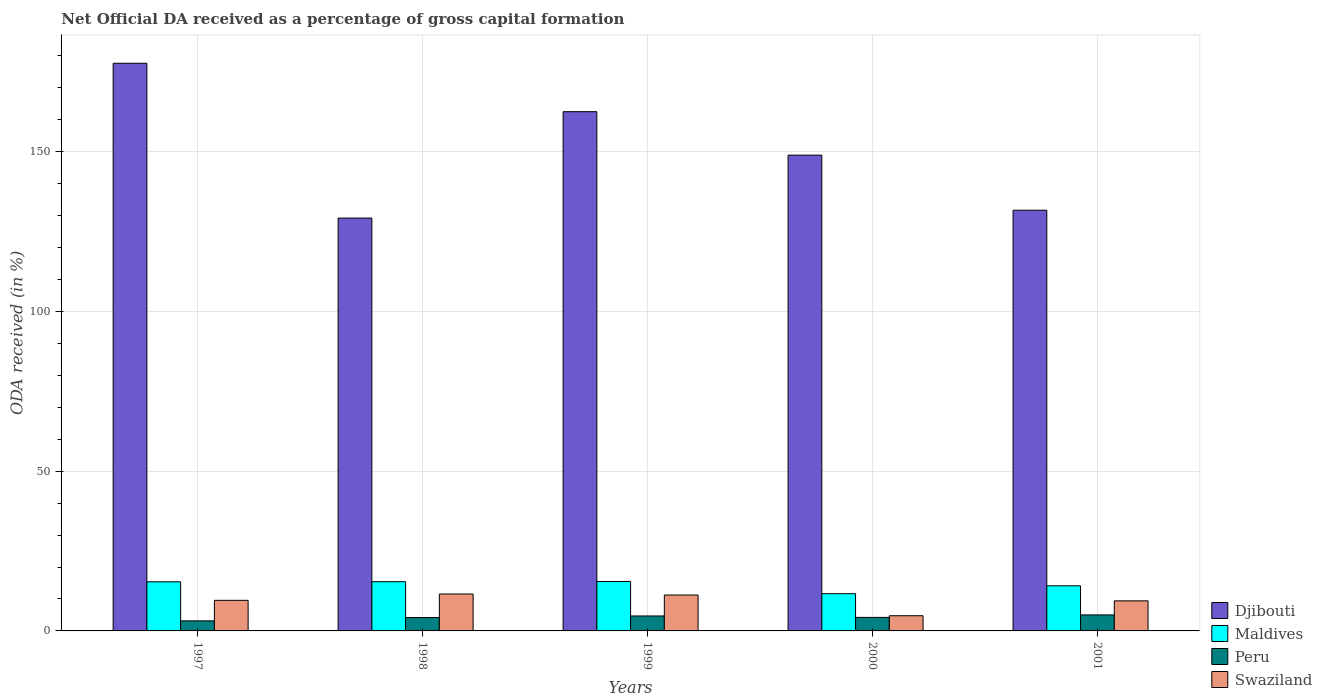How many different coloured bars are there?
Provide a succinct answer. 4. How many bars are there on the 1st tick from the right?
Your answer should be very brief. 4. What is the net ODA received in Djibouti in 1998?
Make the answer very short. 129.18. Across all years, what is the maximum net ODA received in Swaziland?
Your response must be concise. 11.55. Across all years, what is the minimum net ODA received in Djibouti?
Offer a terse response. 129.18. In which year was the net ODA received in Djibouti minimum?
Your response must be concise. 1998. What is the total net ODA received in Peru in the graph?
Your response must be concise. 21.26. What is the difference between the net ODA received in Maldives in 1997 and that in 1998?
Provide a short and direct response. -0.04. What is the difference between the net ODA received in Peru in 2001 and the net ODA received in Djibouti in 1999?
Your answer should be very brief. -157.46. What is the average net ODA received in Peru per year?
Your response must be concise. 4.25. In the year 1997, what is the difference between the net ODA received in Peru and net ODA received in Swaziland?
Your answer should be compact. -6.42. In how many years, is the net ODA received in Swaziland greater than 160 %?
Your response must be concise. 0. What is the ratio of the net ODA received in Peru in 2000 to that in 2001?
Your answer should be very brief. 0.84. Is the net ODA received in Djibouti in 1997 less than that in 2001?
Give a very brief answer. No. Is the difference between the net ODA received in Peru in 1997 and 1998 greater than the difference between the net ODA received in Swaziland in 1997 and 1998?
Your answer should be compact. Yes. What is the difference between the highest and the second highest net ODA received in Djibouti?
Your answer should be compact. 15.15. What is the difference between the highest and the lowest net ODA received in Maldives?
Make the answer very short. 3.83. What does the 4th bar from the left in 2001 represents?
Offer a very short reply. Swaziland. How many bars are there?
Make the answer very short. 20. Does the graph contain any zero values?
Give a very brief answer. No. What is the title of the graph?
Make the answer very short. Net Official DA received as a percentage of gross capital formation. What is the label or title of the Y-axis?
Provide a succinct answer. ODA received (in %). What is the ODA received (in %) in Djibouti in 1997?
Provide a succinct answer. 177.62. What is the ODA received (in %) in Maldives in 1997?
Give a very brief answer. 15.37. What is the ODA received (in %) in Peru in 1997?
Your answer should be compact. 3.14. What is the ODA received (in %) in Swaziland in 1997?
Your answer should be very brief. 9.57. What is the ODA received (in %) of Djibouti in 1998?
Give a very brief answer. 129.18. What is the ODA received (in %) in Maldives in 1998?
Give a very brief answer. 15.4. What is the ODA received (in %) of Peru in 1998?
Make the answer very short. 4.19. What is the ODA received (in %) in Swaziland in 1998?
Your answer should be very brief. 11.55. What is the ODA received (in %) of Djibouti in 1999?
Make the answer very short. 162.47. What is the ODA received (in %) in Maldives in 1999?
Give a very brief answer. 15.48. What is the ODA received (in %) of Peru in 1999?
Keep it short and to the point. 4.68. What is the ODA received (in %) of Swaziland in 1999?
Offer a terse response. 11.23. What is the ODA received (in %) of Djibouti in 2000?
Provide a succinct answer. 148.87. What is the ODA received (in %) in Maldives in 2000?
Offer a very short reply. 11.65. What is the ODA received (in %) of Peru in 2000?
Make the answer very short. 4.23. What is the ODA received (in %) in Swaziland in 2000?
Your answer should be very brief. 4.75. What is the ODA received (in %) in Djibouti in 2001?
Provide a succinct answer. 131.64. What is the ODA received (in %) in Maldives in 2001?
Give a very brief answer. 14.12. What is the ODA received (in %) in Peru in 2001?
Offer a very short reply. 5.01. What is the ODA received (in %) of Swaziland in 2001?
Your answer should be compact. 9.41. Across all years, what is the maximum ODA received (in %) in Djibouti?
Keep it short and to the point. 177.62. Across all years, what is the maximum ODA received (in %) of Maldives?
Offer a terse response. 15.48. Across all years, what is the maximum ODA received (in %) in Peru?
Your answer should be very brief. 5.01. Across all years, what is the maximum ODA received (in %) of Swaziland?
Give a very brief answer. 11.55. Across all years, what is the minimum ODA received (in %) of Djibouti?
Offer a terse response. 129.18. Across all years, what is the minimum ODA received (in %) of Maldives?
Provide a short and direct response. 11.65. Across all years, what is the minimum ODA received (in %) in Peru?
Offer a very short reply. 3.14. Across all years, what is the minimum ODA received (in %) in Swaziland?
Give a very brief answer. 4.75. What is the total ODA received (in %) of Djibouti in the graph?
Your response must be concise. 749.77. What is the total ODA received (in %) in Maldives in the graph?
Keep it short and to the point. 72.01. What is the total ODA received (in %) in Peru in the graph?
Provide a succinct answer. 21.26. What is the total ODA received (in %) of Swaziland in the graph?
Your answer should be very brief. 46.51. What is the difference between the ODA received (in %) in Djibouti in 1997 and that in 1998?
Your answer should be very brief. 48.44. What is the difference between the ODA received (in %) of Maldives in 1997 and that in 1998?
Provide a succinct answer. -0.04. What is the difference between the ODA received (in %) in Peru in 1997 and that in 1998?
Ensure brevity in your answer.  -1.04. What is the difference between the ODA received (in %) of Swaziland in 1997 and that in 1998?
Your response must be concise. -1.98. What is the difference between the ODA received (in %) in Djibouti in 1997 and that in 1999?
Ensure brevity in your answer.  15.15. What is the difference between the ODA received (in %) in Maldives in 1997 and that in 1999?
Keep it short and to the point. -0.11. What is the difference between the ODA received (in %) of Peru in 1997 and that in 1999?
Keep it short and to the point. -1.54. What is the difference between the ODA received (in %) of Swaziland in 1997 and that in 1999?
Offer a terse response. -1.66. What is the difference between the ODA received (in %) of Djibouti in 1997 and that in 2000?
Offer a very short reply. 28.75. What is the difference between the ODA received (in %) in Maldives in 1997 and that in 2000?
Your answer should be very brief. 3.71. What is the difference between the ODA received (in %) in Peru in 1997 and that in 2000?
Your answer should be compact. -1.09. What is the difference between the ODA received (in %) of Swaziland in 1997 and that in 2000?
Keep it short and to the point. 4.81. What is the difference between the ODA received (in %) in Djibouti in 1997 and that in 2001?
Your answer should be very brief. 45.98. What is the difference between the ODA received (in %) of Maldives in 1997 and that in 2001?
Your answer should be compact. 1.25. What is the difference between the ODA received (in %) of Peru in 1997 and that in 2001?
Provide a short and direct response. -1.86. What is the difference between the ODA received (in %) of Swaziland in 1997 and that in 2001?
Provide a short and direct response. 0.16. What is the difference between the ODA received (in %) in Djibouti in 1998 and that in 1999?
Give a very brief answer. -33.29. What is the difference between the ODA received (in %) of Maldives in 1998 and that in 1999?
Your response must be concise. -0.08. What is the difference between the ODA received (in %) of Peru in 1998 and that in 1999?
Offer a terse response. -0.49. What is the difference between the ODA received (in %) in Swaziland in 1998 and that in 1999?
Provide a succinct answer. 0.32. What is the difference between the ODA received (in %) in Djibouti in 1998 and that in 2000?
Provide a succinct answer. -19.69. What is the difference between the ODA received (in %) of Maldives in 1998 and that in 2000?
Provide a succinct answer. 3.75. What is the difference between the ODA received (in %) of Peru in 1998 and that in 2000?
Your answer should be compact. -0.04. What is the difference between the ODA received (in %) of Swaziland in 1998 and that in 2000?
Provide a short and direct response. 6.8. What is the difference between the ODA received (in %) of Djibouti in 1998 and that in 2001?
Keep it short and to the point. -2.46. What is the difference between the ODA received (in %) in Maldives in 1998 and that in 2001?
Ensure brevity in your answer.  1.28. What is the difference between the ODA received (in %) of Peru in 1998 and that in 2001?
Your answer should be compact. -0.82. What is the difference between the ODA received (in %) of Swaziland in 1998 and that in 2001?
Offer a terse response. 2.15. What is the difference between the ODA received (in %) in Djibouti in 1999 and that in 2000?
Ensure brevity in your answer.  13.6. What is the difference between the ODA received (in %) in Maldives in 1999 and that in 2000?
Keep it short and to the point. 3.83. What is the difference between the ODA received (in %) of Peru in 1999 and that in 2000?
Make the answer very short. 0.45. What is the difference between the ODA received (in %) of Swaziland in 1999 and that in 2000?
Ensure brevity in your answer.  6.48. What is the difference between the ODA received (in %) in Djibouti in 1999 and that in 2001?
Your answer should be compact. 30.83. What is the difference between the ODA received (in %) in Maldives in 1999 and that in 2001?
Ensure brevity in your answer.  1.36. What is the difference between the ODA received (in %) of Peru in 1999 and that in 2001?
Keep it short and to the point. -0.33. What is the difference between the ODA received (in %) in Swaziland in 1999 and that in 2001?
Your response must be concise. 1.82. What is the difference between the ODA received (in %) of Djibouti in 2000 and that in 2001?
Offer a terse response. 17.23. What is the difference between the ODA received (in %) in Maldives in 2000 and that in 2001?
Offer a very short reply. -2.46. What is the difference between the ODA received (in %) of Peru in 2000 and that in 2001?
Ensure brevity in your answer.  -0.78. What is the difference between the ODA received (in %) of Swaziland in 2000 and that in 2001?
Ensure brevity in your answer.  -4.65. What is the difference between the ODA received (in %) in Djibouti in 1997 and the ODA received (in %) in Maldives in 1998?
Make the answer very short. 162.22. What is the difference between the ODA received (in %) in Djibouti in 1997 and the ODA received (in %) in Peru in 1998?
Provide a short and direct response. 173.43. What is the difference between the ODA received (in %) in Djibouti in 1997 and the ODA received (in %) in Swaziland in 1998?
Ensure brevity in your answer.  166.07. What is the difference between the ODA received (in %) in Maldives in 1997 and the ODA received (in %) in Peru in 1998?
Provide a short and direct response. 11.18. What is the difference between the ODA received (in %) in Maldives in 1997 and the ODA received (in %) in Swaziland in 1998?
Your answer should be compact. 3.81. What is the difference between the ODA received (in %) of Peru in 1997 and the ODA received (in %) of Swaziland in 1998?
Your answer should be compact. -8.41. What is the difference between the ODA received (in %) in Djibouti in 1997 and the ODA received (in %) in Maldives in 1999?
Your response must be concise. 162.14. What is the difference between the ODA received (in %) of Djibouti in 1997 and the ODA received (in %) of Peru in 1999?
Offer a terse response. 172.94. What is the difference between the ODA received (in %) in Djibouti in 1997 and the ODA received (in %) in Swaziland in 1999?
Your response must be concise. 166.39. What is the difference between the ODA received (in %) in Maldives in 1997 and the ODA received (in %) in Peru in 1999?
Provide a short and direct response. 10.69. What is the difference between the ODA received (in %) in Maldives in 1997 and the ODA received (in %) in Swaziland in 1999?
Provide a succinct answer. 4.13. What is the difference between the ODA received (in %) of Peru in 1997 and the ODA received (in %) of Swaziland in 1999?
Offer a terse response. -8.09. What is the difference between the ODA received (in %) in Djibouti in 1997 and the ODA received (in %) in Maldives in 2000?
Your answer should be very brief. 165.96. What is the difference between the ODA received (in %) in Djibouti in 1997 and the ODA received (in %) in Peru in 2000?
Give a very brief answer. 173.39. What is the difference between the ODA received (in %) in Djibouti in 1997 and the ODA received (in %) in Swaziland in 2000?
Offer a terse response. 172.86. What is the difference between the ODA received (in %) in Maldives in 1997 and the ODA received (in %) in Peru in 2000?
Keep it short and to the point. 11.13. What is the difference between the ODA received (in %) in Maldives in 1997 and the ODA received (in %) in Swaziland in 2000?
Make the answer very short. 10.61. What is the difference between the ODA received (in %) in Peru in 1997 and the ODA received (in %) in Swaziland in 2000?
Your answer should be compact. -1.61. What is the difference between the ODA received (in %) in Djibouti in 1997 and the ODA received (in %) in Maldives in 2001?
Provide a short and direct response. 163.5. What is the difference between the ODA received (in %) in Djibouti in 1997 and the ODA received (in %) in Peru in 2001?
Offer a terse response. 172.61. What is the difference between the ODA received (in %) in Djibouti in 1997 and the ODA received (in %) in Swaziland in 2001?
Offer a very short reply. 168.21. What is the difference between the ODA received (in %) in Maldives in 1997 and the ODA received (in %) in Peru in 2001?
Offer a terse response. 10.36. What is the difference between the ODA received (in %) of Maldives in 1997 and the ODA received (in %) of Swaziland in 2001?
Keep it short and to the point. 5.96. What is the difference between the ODA received (in %) of Peru in 1997 and the ODA received (in %) of Swaziland in 2001?
Make the answer very short. -6.26. What is the difference between the ODA received (in %) of Djibouti in 1998 and the ODA received (in %) of Maldives in 1999?
Your answer should be compact. 113.7. What is the difference between the ODA received (in %) of Djibouti in 1998 and the ODA received (in %) of Peru in 1999?
Give a very brief answer. 124.5. What is the difference between the ODA received (in %) in Djibouti in 1998 and the ODA received (in %) in Swaziland in 1999?
Ensure brevity in your answer.  117.95. What is the difference between the ODA received (in %) in Maldives in 1998 and the ODA received (in %) in Peru in 1999?
Your answer should be compact. 10.72. What is the difference between the ODA received (in %) of Maldives in 1998 and the ODA received (in %) of Swaziland in 1999?
Offer a very short reply. 4.17. What is the difference between the ODA received (in %) of Peru in 1998 and the ODA received (in %) of Swaziland in 1999?
Provide a short and direct response. -7.04. What is the difference between the ODA received (in %) of Djibouti in 1998 and the ODA received (in %) of Maldives in 2000?
Provide a short and direct response. 117.53. What is the difference between the ODA received (in %) of Djibouti in 1998 and the ODA received (in %) of Peru in 2000?
Ensure brevity in your answer.  124.95. What is the difference between the ODA received (in %) of Djibouti in 1998 and the ODA received (in %) of Swaziland in 2000?
Your answer should be very brief. 124.43. What is the difference between the ODA received (in %) of Maldives in 1998 and the ODA received (in %) of Peru in 2000?
Give a very brief answer. 11.17. What is the difference between the ODA received (in %) in Maldives in 1998 and the ODA received (in %) in Swaziland in 2000?
Make the answer very short. 10.65. What is the difference between the ODA received (in %) of Peru in 1998 and the ODA received (in %) of Swaziland in 2000?
Make the answer very short. -0.56. What is the difference between the ODA received (in %) in Djibouti in 1998 and the ODA received (in %) in Maldives in 2001?
Ensure brevity in your answer.  115.06. What is the difference between the ODA received (in %) in Djibouti in 1998 and the ODA received (in %) in Peru in 2001?
Keep it short and to the point. 124.17. What is the difference between the ODA received (in %) of Djibouti in 1998 and the ODA received (in %) of Swaziland in 2001?
Your answer should be compact. 119.77. What is the difference between the ODA received (in %) of Maldives in 1998 and the ODA received (in %) of Peru in 2001?
Provide a short and direct response. 10.39. What is the difference between the ODA received (in %) in Maldives in 1998 and the ODA received (in %) in Swaziland in 2001?
Your answer should be very brief. 6. What is the difference between the ODA received (in %) in Peru in 1998 and the ODA received (in %) in Swaziland in 2001?
Keep it short and to the point. -5.22. What is the difference between the ODA received (in %) in Djibouti in 1999 and the ODA received (in %) in Maldives in 2000?
Give a very brief answer. 150.82. What is the difference between the ODA received (in %) of Djibouti in 1999 and the ODA received (in %) of Peru in 2000?
Provide a succinct answer. 158.24. What is the difference between the ODA received (in %) in Djibouti in 1999 and the ODA received (in %) in Swaziland in 2000?
Offer a very short reply. 157.71. What is the difference between the ODA received (in %) of Maldives in 1999 and the ODA received (in %) of Peru in 2000?
Make the answer very short. 11.25. What is the difference between the ODA received (in %) in Maldives in 1999 and the ODA received (in %) in Swaziland in 2000?
Make the answer very short. 10.72. What is the difference between the ODA received (in %) of Peru in 1999 and the ODA received (in %) of Swaziland in 2000?
Offer a very short reply. -0.07. What is the difference between the ODA received (in %) in Djibouti in 1999 and the ODA received (in %) in Maldives in 2001?
Provide a short and direct response. 148.35. What is the difference between the ODA received (in %) of Djibouti in 1999 and the ODA received (in %) of Peru in 2001?
Your answer should be compact. 157.46. What is the difference between the ODA received (in %) of Djibouti in 1999 and the ODA received (in %) of Swaziland in 2001?
Ensure brevity in your answer.  153.06. What is the difference between the ODA received (in %) of Maldives in 1999 and the ODA received (in %) of Peru in 2001?
Ensure brevity in your answer.  10.47. What is the difference between the ODA received (in %) in Maldives in 1999 and the ODA received (in %) in Swaziland in 2001?
Ensure brevity in your answer.  6.07. What is the difference between the ODA received (in %) in Peru in 1999 and the ODA received (in %) in Swaziland in 2001?
Keep it short and to the point. -4.73. What is the difference between the ODA received (in %) in Djibouti in 2000 and the ODA received (in %) in Maldives in 2001?
Ensure brevity in your answer.  134.75. What is the difference between the ODA received (in %) in Djibouti in 2000 and the ODA received (in %) in Peru in 2001?
Your answer should be compact. 143.86. What is the difference between the ODA received (in %) of Djibouti in 2000 and the ODA received (in %) of Swaziland in 2001?
Your answer should be compact. 139.46. What is the difference between the ODA received (in %) of Maldives in 2000 and the ODA received (in %) of Peru in 2001?
Give a very brief answer. 6.64. What is the difference between the ODA received (in %) in Maldives in 2000 and the ODA received (in %) in Swaziland in 2001?
Offer a very short reply. 2.25. What is the difference between the ODA received (in %) in Peru in 2000 and the ODA received (in %) in Swaziland in 2001?
Keep it short and to the point. -5.18. What is the average ODA received (in %) in Djibouti per year?
Your response must be concise. 149.95. What is the average ODA received (in %) of Maldives per year?
Provide a short and direct response. 14.4. What is the average ODA received (in %) in Peru per year?
Keep it short and to the point. 4.25. What is the average ODA received (in %) in Swaziland per year?
Provide a short and direct response. 9.3. In the year 1997, what is the difference between the ODA received (in %) in Djibouti and ODA received (in %) in Maldives?
Offer a terse response. 162.25. In the year 1997, what is the difference between the ODA received (in %) of Djibouti and ODA received (in %) of Peru?
Offer a very short reply. 174.47. In the year 1997, what is the difference between the ODA received (in %) of Djibouti and ODA received (in %) of Swaziland?
Your answer should be very brief. 168.05. In the year 1997, what is the difference between the ODA received (in %) of Maldives and ODA received (in %) of Peru?
Keep it short and to the point. 12.22. In the year 1997, what is the difference between the ODA received (in %) in Maldives and ODA received (in %) in Swaziland?
Make the answer very short. 5.8. In the year 1997, what is the difference between the ODA received (in %) in Peru and ODA received (in %) in Swaziland?
Keep it short and to the point. -6.42. In the year 1998, what is the difference between the ODA received (in %) of Djibouti and ODA received (in %) of Maldives?
Provide a succinct answer. 113.78. In the year 1998, what is the difference between the ODA received (in %) in Djibouti and ODA received (in %) in Peru?
Offer a very short reply. 124.99. In the year 1998, what is the difference between the ODA received (in %) in Djibouti and ODA received (in %) in Swaziland?
Offer a terse response. 117.63. In the year 1998, what is the difference between the ODA received (in %) in Maldives and ODA received (in %) in Peru?
Your response must be concise. 11.21. In the year 1998, what is the difference between the ODA received (in %) in Maldives and ODA received (in %) in Swaziland?
Your response must be concise. 3.85. In the year 1998, what is the difference between the ODA received (in %) of Peru and ODA received (in %) of Swaziland?
Offer a terse response. -7.36. In the year 1999, what is the difference between the ODA received (in %) of Djibouti and ODA received (in %) of Maldives?
Keep it short and to the point. 146.99. In the year 1999, what is the difference between the ODA received (in %) in Djibouti and ODA received (in %) in Peru?
Ensure brevity in your answer.  157.79. In the year 1999, what is the difference between the ODA received (in %) in Djibouti and ODA received (in %) in Swaziland?
Give a very brief answer. 151.24. In the year 1999, what is the difference between the ODA received (in %) of Maldives and ODA received (in %) of Peru?
Your answer should be compact. 10.8. In the year 1999, what is the difference between the ODA received (in %) in Maldives and ODA received (in %) in Swaziland?
Provide a short and direct response. 4.25. In the year 1999, what is the difference between the ODA received (in %) in Peru and ODA received (in %) in Swaziland?
Give a very brief answer. -6.55. In the year 2000, what is the difference between the ODA received (in %) in Djibouti and ODA received (in %) in Maldives?
Ensure brevity in your answer.  137.22. In the year 2000, what is the difference between the ODA received (in %) in Djibouti and ODA received (in %) in Peru?
Make the answer very short. 144.64. In the year 2000, what is the difference between the ODA received (in %) in Djibouti and ODA received (in %) in Swaziland?
Provide a short and direct response. 144.12. In the year 2000, what is the difference between the ODA received (in %) of Maldives and ODA received (in %) of Peru?
Your answer should be very brief. 7.42. In the year 2000, what is the difference between the ODA received (in %) in Maldives and ODA received (in %) in Swaziland?
Offer a very short reply. 6.9. In the year 2000, what is the difference between the ODA received (in %) in Peru and ODA received (in %) in Swaziland?
Offer a very short reply. -0.52. In the year 2001, what is the difference between the ODA received (in %) of Djibouti and ODA received (in %) of Maldives?
Keep it short and to the point. 117.52. In the year 2001, what is the difference between the ODA received (in %) in Djibouti and ODA received (in %) in Peru?
Offer a terse response. 126.63. In the year 2001, what is the difference between the ODA received (in %) of Djibouti and ODA received (in %) of Swaziland?
Ensure brevity in your answer.  122.23. In the year 2001, what is the difference between the ODA received (in %) in Maldives and ODA received (in %) in Peru?
Provide a succinct answer. 9.11. In the year 2001, what is the difference between the ODA received (in %) in Maldives and ODA received (in %) in Swaziland?
Ensure brevity in your answer.  4.71. In the year 2001, what is the difference between the ODA received (in %) of Peru and ODA received (in %) of Swaziland?
Offer a very short reply. -4.4. What is the ratio of the ODA received (in %) in Djibouti in 1997 to that in 1998?
Provide a succinct answer. 1.38. What is the ratio of the ODA received (in %) in Maldives in 1997 to that in 1998?
Your answer should be very brief. 1. What is the ratio of the ODA received (in %) in Peru in 1997 to that in 1998?
Give a very brief answer. 0.75. What is the ratio of the ODA received (in %) in Swaziland in 1997 to that in 1998?
Offer a terse response. 0.83. What is the ratio of the ODA received (in %) of Djibouti in 1997 to that in 1999?
Provide a short and direct response. 1.09. What is the ratio of the ODA received (in %) in Maldives in 1997 to that in 1999?
Make the answer very short. 0.99. What is the ratio of the ODA received (in %) in Peru in 1997 to that in 1999?
Your answer should be compact. 0.67. What is the ratio of the ODA received (in %) of Swaziland in 1997 to that in 1999?
Provide a short and direct response. 0.85. What is the ratio of the ODA received (in %) in Djibouti in 1997 to that in 2000?
Offer a terse response. 1.19. What is the ratio of the ODA received (in %) of Maldives in 1997 to that in 2000?
Your answer should be very brief. 1.32. What is the ratio of the ODA received (in %) in Peru in 1997 to that in 2000?
Give a very brief answer. 0.74. What is the ratio of the ODA received (in %) in Swaziland in 1997 to that in 2000?
Ensure brevity in your answer.  2.01. What is the ratio of the ODA received (in %) of Djibouti in 1997 to that in 2001?
Offer a very short reply. 1.35. What is the ratio of the ODA received (in %) in Maldives in 1997 to that in 2001?
Offer a very short reply. 1.09. What is the ratio of the ODA received (in %) of Peru in 1997 to that in 2001?
Offer a terse response. 0.63. What is the ratio of the ODA received (in %) of Swaziland in 1997 to that in 2001?
Ensure brevity in your answer.  1.02. What is the ratio of the ODA received (in %) in Djibouti in 1998 to that in 1999?
Your answer should be compact. 0.8. What is the ratio of the ODA received (in %) in Maldives in 1998 to that in 1999?
Provide a succinct answer. 1. What is the ratio of the ODA received (in %) in Peru in 1998 to that in 1999?
Offer a terse response. 0.9. What is the ratio of the ODA received (in %) of Swaziland in 1998 to that in 1999?
Provide a short and direct response. 1.03. What is the ratio of the ODA received (in %) in Djibouti in 1998 to that in 2000?
Offer a terse response. 0.87. What is the ratio of the ODA received (in %) of Maldives in 1998 to that in 2000?
Keep it short and to the point. 1.32. What is the ratio of the ODA received (in %) in Swaziland in 1998 to that in 2000?
Give a very brief answer. 2.43. What is the ratio of the ODA received (in %) of Djibouti in 1998 to that in 2001?
Your response must be concise. 0.98. What is the ratio of the ODA received (in %) in Maldives in 1998 to that in 2001?
Ensure brevity in your answer.  1.09. What is the ratio of the ODA received (in %) of Peru in 1998 to that in 2001?
Provide a short and direct response. 0.84. What is the ratio of the ODA received (in %) of Swaziland in 1998 to that in 2001?
Provide a succinct answer. 1.23. What is the ratio of the ODA received (in %) of Djibouti in 1999 to that in 2000?
Offer a very short reply. 1.09. What is the ratio of the ODA received (in %) in Maldives in 1999 to that in 2000?
Provide a succinct answer. 1.33. What is the ratio of the ODA received (in %) in Peru in 1999 to that in 2000?
Offer a terse response. 1.11. What is the ratio of the ODA received (in %) of Swaziland in 1999 to that in 2000?
Ensure brevity in your answer.  2.36. What is the ratio of the ODA received (in %) of Djibouti in 1999 to that in 2001?
Your response must be concise. 1.23. What is the ratio of the ODA received (in %) in Maldives in 1999 to that in 2001?
Ensure brevity in your answer.  1.1. What is the ratio of the ODA received (in %) in Peru in 1999 to that in 2001?
Provide a short and direct response. 0.93. What is the ratio of the ODA received (in %) in Swaziland in 1999 to that in 2001?
Ensure brevity in your answer.  1.19. What is the ratio of the ODA received (in %) in Djibouti in 2000 to that in 2001?
Ensure brevity in your answer.  1.13. What is the ratio of the ODA received (in %) of Maldives in 2000 to that in 2001?
Ensure brevity in your answer.  0.83. What is the ratio of the ODA received (in %) in Peru in 2000 to that in 2001?
Keep it short and to the point. 0.84. What is the ratio of the ODA received (in %) of Swaziland in 2000 to that in 2001?
Offer a terse response. 0.51. What is the difference between the highest and the second highest ODA received (in %) of Djibouti?
Ensure brevity in your answer.  15.15. What is the difference between the highest and the second highest ODA received (in %) of Maldives?
Ensure brevity in your answer.  0.08. What is the difference between the highest and the second highest ODA received (in %) in Peru?
Your answer should be compact. 0.33. What is the difference between the highest and the second highest ODA received (in %) in Swaziland?
Offer a very short reply. 0.32. What is the difference between the highest and the lowest ODA received (in %) in Djibouti?
Make the answer very short. 48.44. What is the difference between the highest and the lowest ODA received (in %) in Maldives?
Your answer should be compact. 3.83. What is the difference between the highest and the lowest ODA received (in %) of Peru?
Your answer should be very brief. 1.86. What is the difference between the highest and the lowest ODA received (in %) of Swaziland?
Keep it short and to the point. 6.8. 